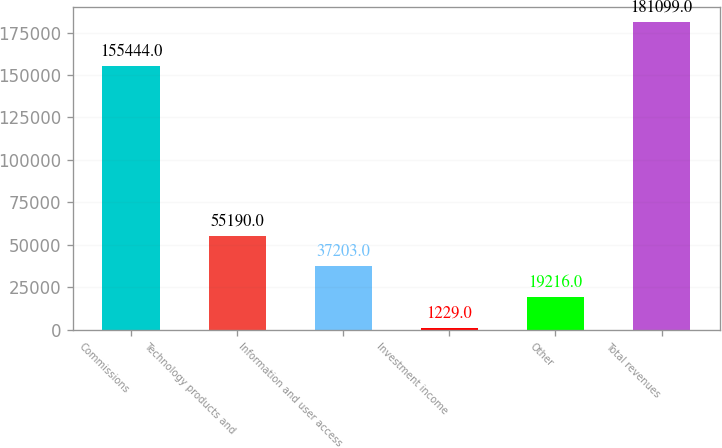Convert chart to OTSL. <chart><loc_0><loc_0><loc_500><loc_500><bar_chart><fcel>Commissions<fcel>Technology products and<fcel>Information and user access<fcel>Investment income<fcel>Other<fcel>Total revenues<nl><fcel>155444<fcel>55190<fcel>37203<fcel>1229<fcel>19216<fcel>181099<nl></chart> 